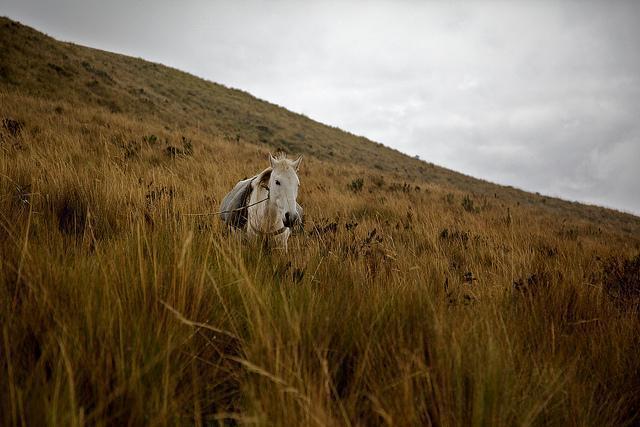How many white cars are there?
Give a very brief answer. 0. 